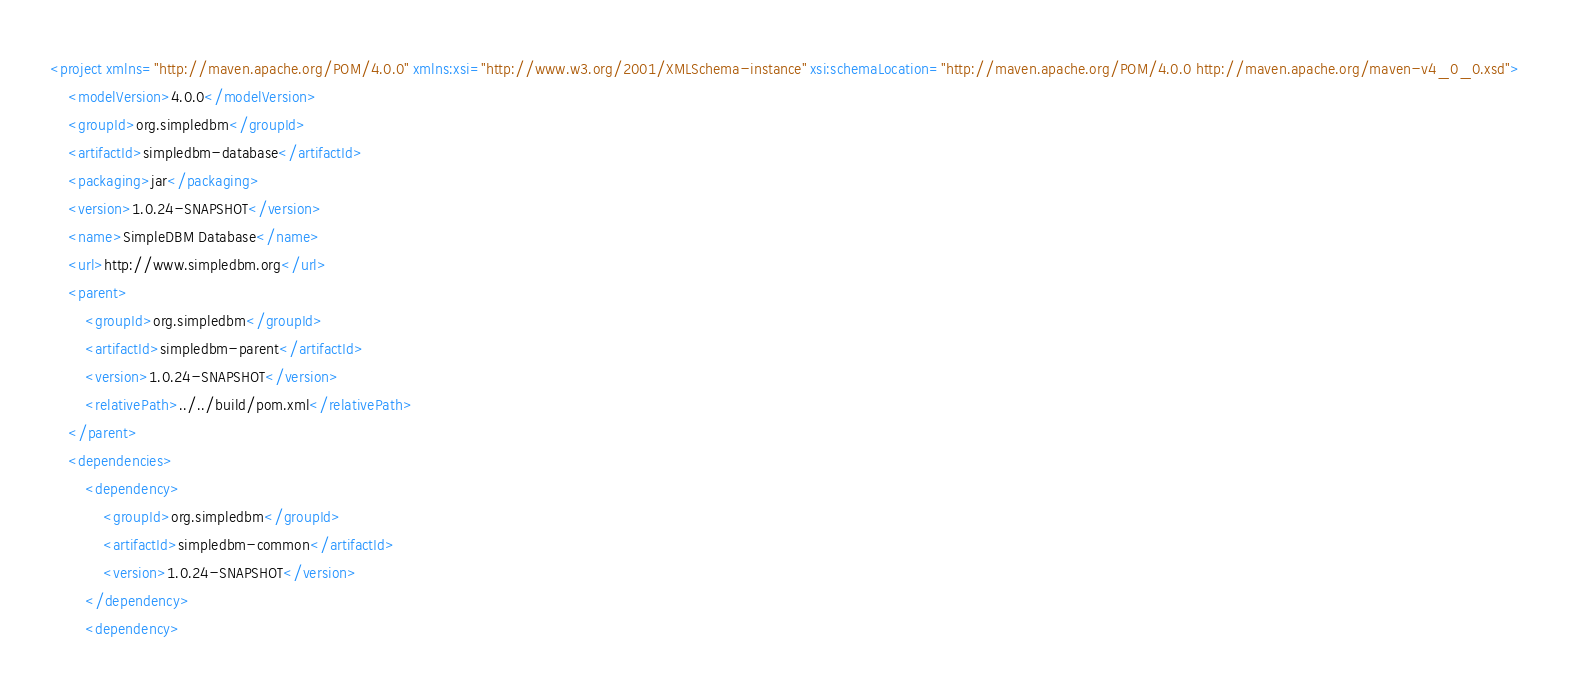Convert code to text. <code><loc_0><loc_0><loc_500><loc_500><_XML_><project xmlns="http://maven.apache.org/POM/4.0.0" xmlns:xsi="http://www.w3.org/2001/XMLSchema-instance" xsi:schemaLocation="http://maven.apache.org/POM/4.0.0 http://maven.apache.org/maven-v4_0_0.xsd">
    <modelVersion>4.0.0</modelVersion>
    <groupId>org.simpledbm</groupId>
    <artifactId>simpledbm-database</artifactId>
    <packaging>jar</packaging>
    <version>1.0.24-SNAPSHOT</version>
    <name>SimpleDBM Database</name>
    <url>http://www.simpledbm.org</url>
    <parent>
        <groupId>org.simpledbm</groupId>
        <artifactId>simpledbm-parent</artifactId>
        <version>1.0.24-SNAPSHOT</version>
        <relativePath>../../build/pom.xml</relativePath>
    </parent>
    <dependencies>
        <dependency>
            <groupId>org.simpledbm</groupId>
            <artifactId>simpledbm-common</artifactId>
            <version>1.0.24-SNAPSHOT</version>
        </dependency>
        <dependency></code> 